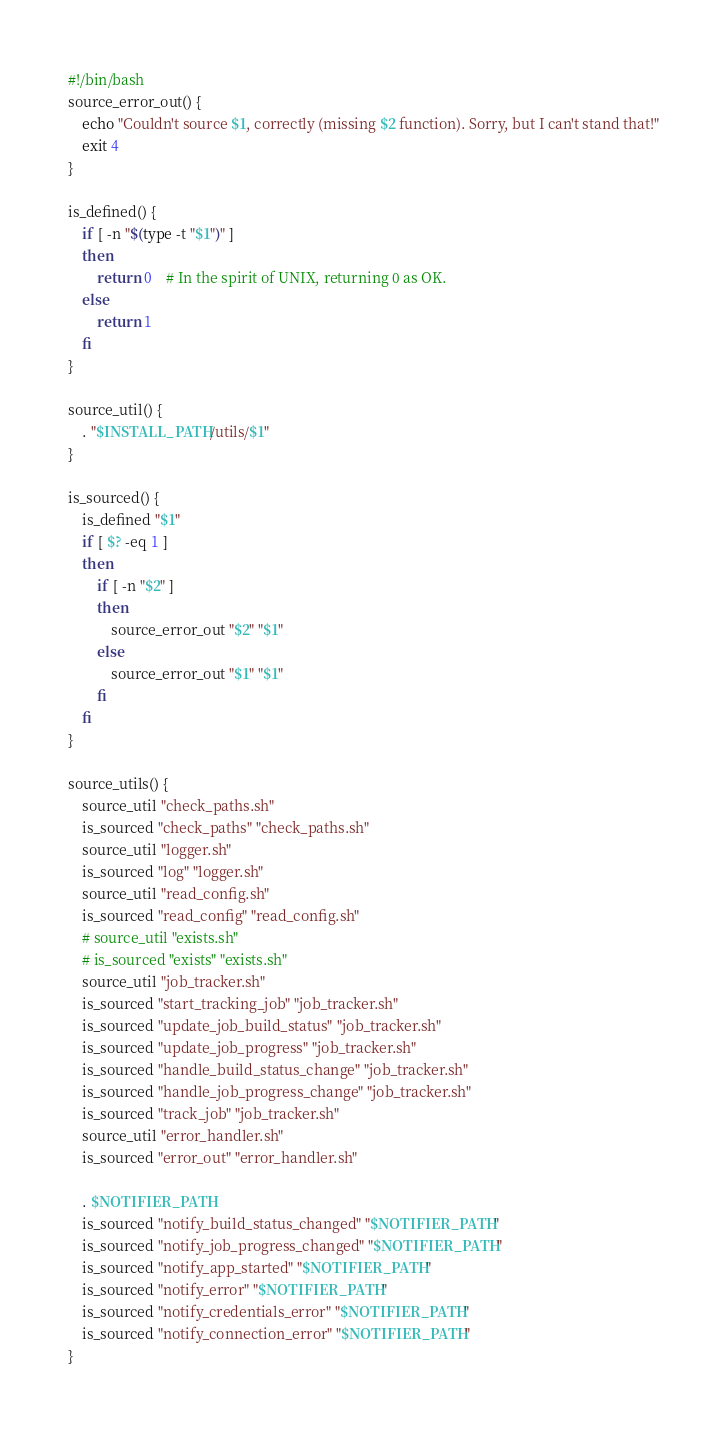Convert code to text. <code><loc_0><loc_0><loc_500><loc_500><_Bash_>#!/bin/bash
source_error_out() {
    echo "Couldn't source $1, correctly (missing $2 function). Sorry, but I can't stand that!"
    exit 4
}

is_defined() {
    if [ -n "$(type -t "$1")" ]
    then
        return 0    # In the spirit of UNIX, returning 0 as OK.
    else
        return 1
    fi
}

source_util() {
    . "$INSTALL_PATH/utils/$1"
}

is_sourced() {
    is_defined "$1"
    if [ $? -eq 1 ]
    then
        if [ -n "$2" ]
        then
            source_error_out "$2" "$1"
        else
            source_error_out "$1" "$1"
        fi
    fi
}

source_utils() {
    source_util "check_paths.sh"
    is_sourced "check_paths" "check_paths.sh"
    source_util "logger.sh"
    is_sourced "log" "logger.sh"
    source_util "read_config.sh"
    is_sourced "read_config" "read_config.sh"
    # source_util "exists.sh"
    # is_sourced "exists" "exists.sh"
    source_util "job_tracker.sh"
    is_sourced "start_tracking_job" "job_tracker.sh"
    is_sourced "update_job_build_status" "job_tracker.sh"
    is_sourced "update_job_progress" "job_tracker.sh"
    is_sourced "handle_build_status_change" "job_tracker.sh"
    is_sourced "handle_job_progress_change" "job_tracker.sh"
    is_sourced "track_job" "job_tracker.sh"
    source_util "error_handler.sh"
    is_sourced "error_out" "error_handler.sh"

    . $NOTIFIER_PATH
    is_sourced "notify_build_status_changed" "$NOTIFIER_PATH"
    is_sourced "notify_job_progress_changed" "$NOTIFIER_PATH"
    is_sourced "notify_app_started" "$NOTIFIER_PATH"
    is_sourced "notify_error" "$NOTIFIER_PATH"
    is_sourced "notify_credentials_error" "$NOTIFIER_PATH"
    is_sourced "notify_connection_error" "$NOTIFIER_PATH"
}
</code> 